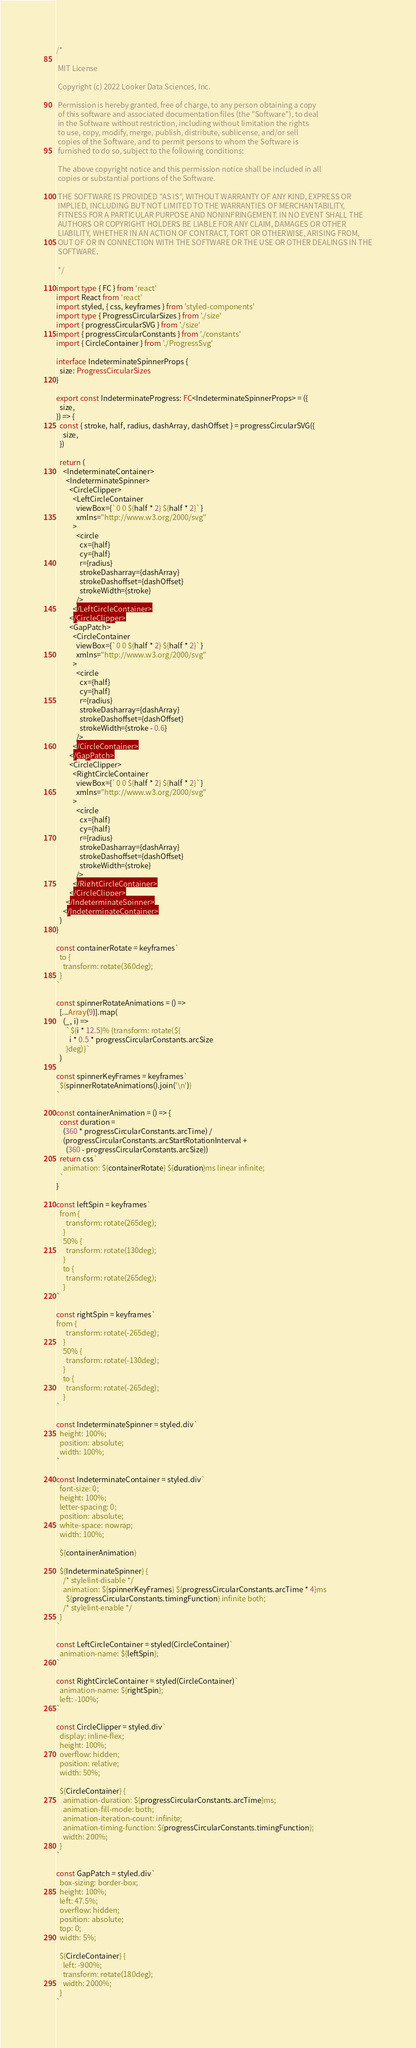<code> <loc_0><loc_0><loc_500><loc_500><_TypeScript_>/*

 MIT License

 Copyright (c) 2022 Looker Data Sciences, Inc.

 Permission is hereby granted, free of charge, to any person obtaining a copy
 of this software and associated documentation files (the "Software"), to deal
 in the Software without restriction, including without limitation the rights
 to use, copy, modify, merge, publish, distribute, sublicense, and/or sell
 copies of the Software, and to permit persons to whom the Software is
 furnished to do so, subject to the following conditions:

 The above copyright notice and this permission notice shall be included in all
 copies or substantial portions of the Software.

 THE SOFTWARE IS PROVIDED "AS IS", WITHOUT WARRANTY OF ANY KIND, EXPRESS OR
 IMPLIED, INCLUDING BUT NOT LIMITED TO THE WARRANTIES OF MERCHANTABILITY,
 FITNESS FOR A PARTICULAR PURPOSE AND NONINFRINGEMENT. IN NO EVENT SHALL THE
 AUTHORS OR COPYRIGHT HOLDERS BE LIABLE FOR ANY CLAIM, DAMAGES OR OTHER
 LIABILITY, WHETHER IN AN ACTION OF CONTRACT, TORT OR OTHERWISE, ARISING FROM,
 OUT OF OR IN CONNECTION WITH THE SOFTWARE OR THE USE OR OTHER DEALINGS IN THE
 SOFTWARE.

 */

import type { FC } from 'react'
import React from 'react'
import styled, { css, keyframes } from 'styled-components'
import type { ProgressCircularSizes } from './size'
import { progressCircularSVG } from './size'
import { progressCircularConstants } from './constants'
import { CircleContainer } from './ProgressSvg'

interface IndeterminateSpinnerProps {
  size: ProgressCircularSizes
}

export const IndeterminateProgress: FC<IndeterminateSpinnerProps> = ({
  size,
}) => {
  const { stroke, half, radius, dashArray, dashOffset } = progressCircularSVG({
    size,
  })

  return (
    <IndeterminateContainer>
      <IndeterminateSpinner>
        <CircleClipper>
          <LeftCircleContainer
            viewBox={`0 0 ${half * 2} ${half * 2}`}
            xmlns="http://www.w3.org/2000/svg"
          >
            <circle
              cx={half}
              cy={half}
              r={radius}
              strokeDasharray={dashArray}
              strokeDashoffset={dashOffset}
              strokeWidth={stroke}
            />
          </LeftCircleContainer>
        </CircleClipper>
        <GapPatch>
          <CircleContainer
            viewBox={`0 0 ${half * 2} ${half * 2}`}
            xmlns="http://www.w3.org/2000/svg"
          >
            <circle
              cx={half}
              cy={half}
              r={radius}
              strokeDasharray={dashArray}
              strokeDashoffset={dashOffset}
              strokeWidth={stroke - 0.6}
            />
          </CircleContainer>
        </GapPatch>
        <CircleClipper>
          <RightCircleContainer
            viewBox={`0 0 ${half * 2} ${half * 2}`}
            xmlns="http://www.w3.org/2000/svg"
          >
            <circle
              cx={half}
              cy={half}
              r={radius}
              strokeDasharray={dashArray}
              strokeDashoffset={dashOffset}
              strokeWidth={stroke}
            />
          </RightCircleContainer>
        </CircleClipper>
      </IndeterminateSpinner>
    </IndeterminateContainer>
  )
}

const containerRotate = keyframes`
  to {
    transform: rotate(360deg);
  }
`

const spinnerRotateAnimations = () =>
  [...Array(9)].map(
    (_, i) =>
      `${i * 12.5}% {transform: rotate(${
        i * 0.5 * progressCircularConstants.arcSize
      }deg)}`
  )

const spinnerKeyFrames = keyframes`
  ${spinnerRotateAnimations().join('\n')}
`

const containerAnimation = () => {
  const duration =
    (360 * progressCircularConstants.arcTime) /
    (progressCircularConstants.arcStartRotationInterval +
      (360 - progressCircularConstants.arcSize))
  return css`
    animation: ${containerRotate} ${duration}ms linear infinite;
  `
}

const leftSpin = keyframes`
  from {
      transform: rotate(265deg);
    }
    50% {
      transform: rotate(130deg);
    }
    to {
      transform: rotate(265deg);
    }
`

const rightSpin = keyframes`
from {
      transform: rotate(-265deg);
    }
    50% {
      transform: rotate(-130deg);
    }
    to {
      transform: rotate(-265deg);
    }
`

const IndeterminateSpinner = styled.div`
  height: 100%;
  position: absolute;
  width: 100%;
`

const IndeterminateContainer = styled.div`
  font-size: 0;
  height: 100%;
  letter-spacing: 0;
  position: absolute;
  white-space: nowrap;
  width: 100%;

  ${containerAnimation}

  ${IndeterminateSpinner} {
    /* stylelint-disable */
    animation: ${spinnerKeyFrames} ${progressCircularConstants.arcTime * 4}ms
      ${progressCircularConstants.timingFunction} infinite both;
    /* stylelint-enable */
  }
`

const LeftCircleContainer = styled(CircleContainer)`
  animation-name: ${leftSpin};
`

const RightCircleContainer = styled(CircleContainer)`
  animation-name: ${rightSpin};
  left: -100%;
`

const CircleClipper = styled.div`
  display: inline-flex;
  height: 100%;
  overflow: hidden;
  position: relative;
  width: 50%;

  ${CircleContainer} {
    animation-duration: ${progressCircularConstants.arcTime}ms;
    animation-fill-mode: both;
    animation-iteration-count: infinite;
    animation-timing-function: ${progressCircularConstants.timingFunction};
    width: 200%;
  }
`

const GapPatch = styled.div`
  box-sizing: border-box;
  height: 100%;
  left: 47.5%;
  overflow: hidden;
  position: absolute;
  top: 0;
  width: 5%;

  ${CircleContainer} {
    left: -900%;
    transform: rotate(180deg);
    width: 2000%;
  }
`
</code> 